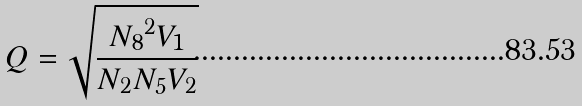Convert formula to latex. <formula><loc_0><loc_0><loc_500><loc_500>Q = \sqrt { \frac { { N _ { 8 } } ^ { 2 } V _ { 1 } } { N _ { 2 } N _ { 5 } V _ { 2 } } }</formula> 